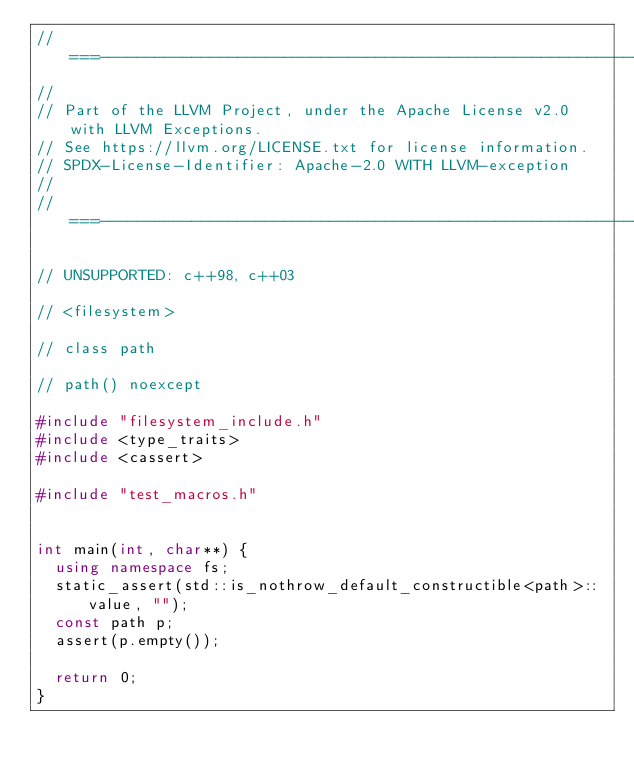<code> <loc_0><loc_0><loc_500><loc_500><_C++_>//===----------------------------------------------------------------------===//
//
// Part of the LLVM Project, under the Apache License v2.0 with LLVM Exceptions.
// See https://llvm.org/LICENSE.txt for license information.
// SPDX-License-Identifier: Apache-2.0 WITH LLVM-exception
//
//===----------------------------------------------------------------------===//

// UNSUPPORTED: c++98, c++03

// <filesystem>

// class path

// path() noexcept

#include "filesystem_include.h"
#include <type_traits>
#include <cassert>

#include "test_macros.h"


int main(int, char**) {
  using namespace fs;
  static_assert(std::is_nothrow_default_constructible<path>::value, "");
  const path p;
  assert(p.empty());

  return 0;
}
</code> 